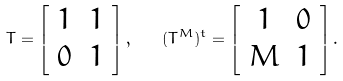Convert formula to latex. <formula><loc_0><loc_0><loc_500><loc_500>T = \left [ \begin{array} { c c } 1 & 1 \\ 0 & 1 \\ \end{array} \right ] , \quad ( T ^ { M } ) ^ { t } = \left [ \begin{array} { c c } 1 & 0 \\ M & 1 \\ \end{array} \right ] .</formula> 